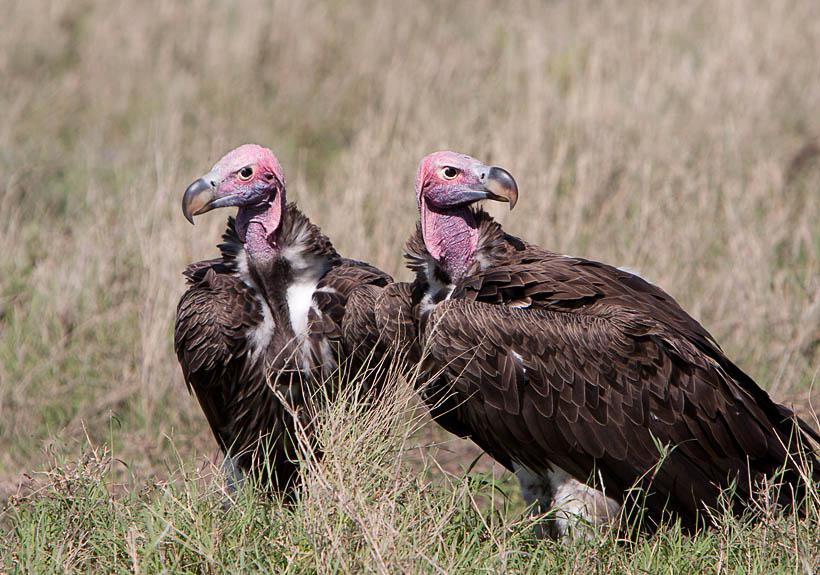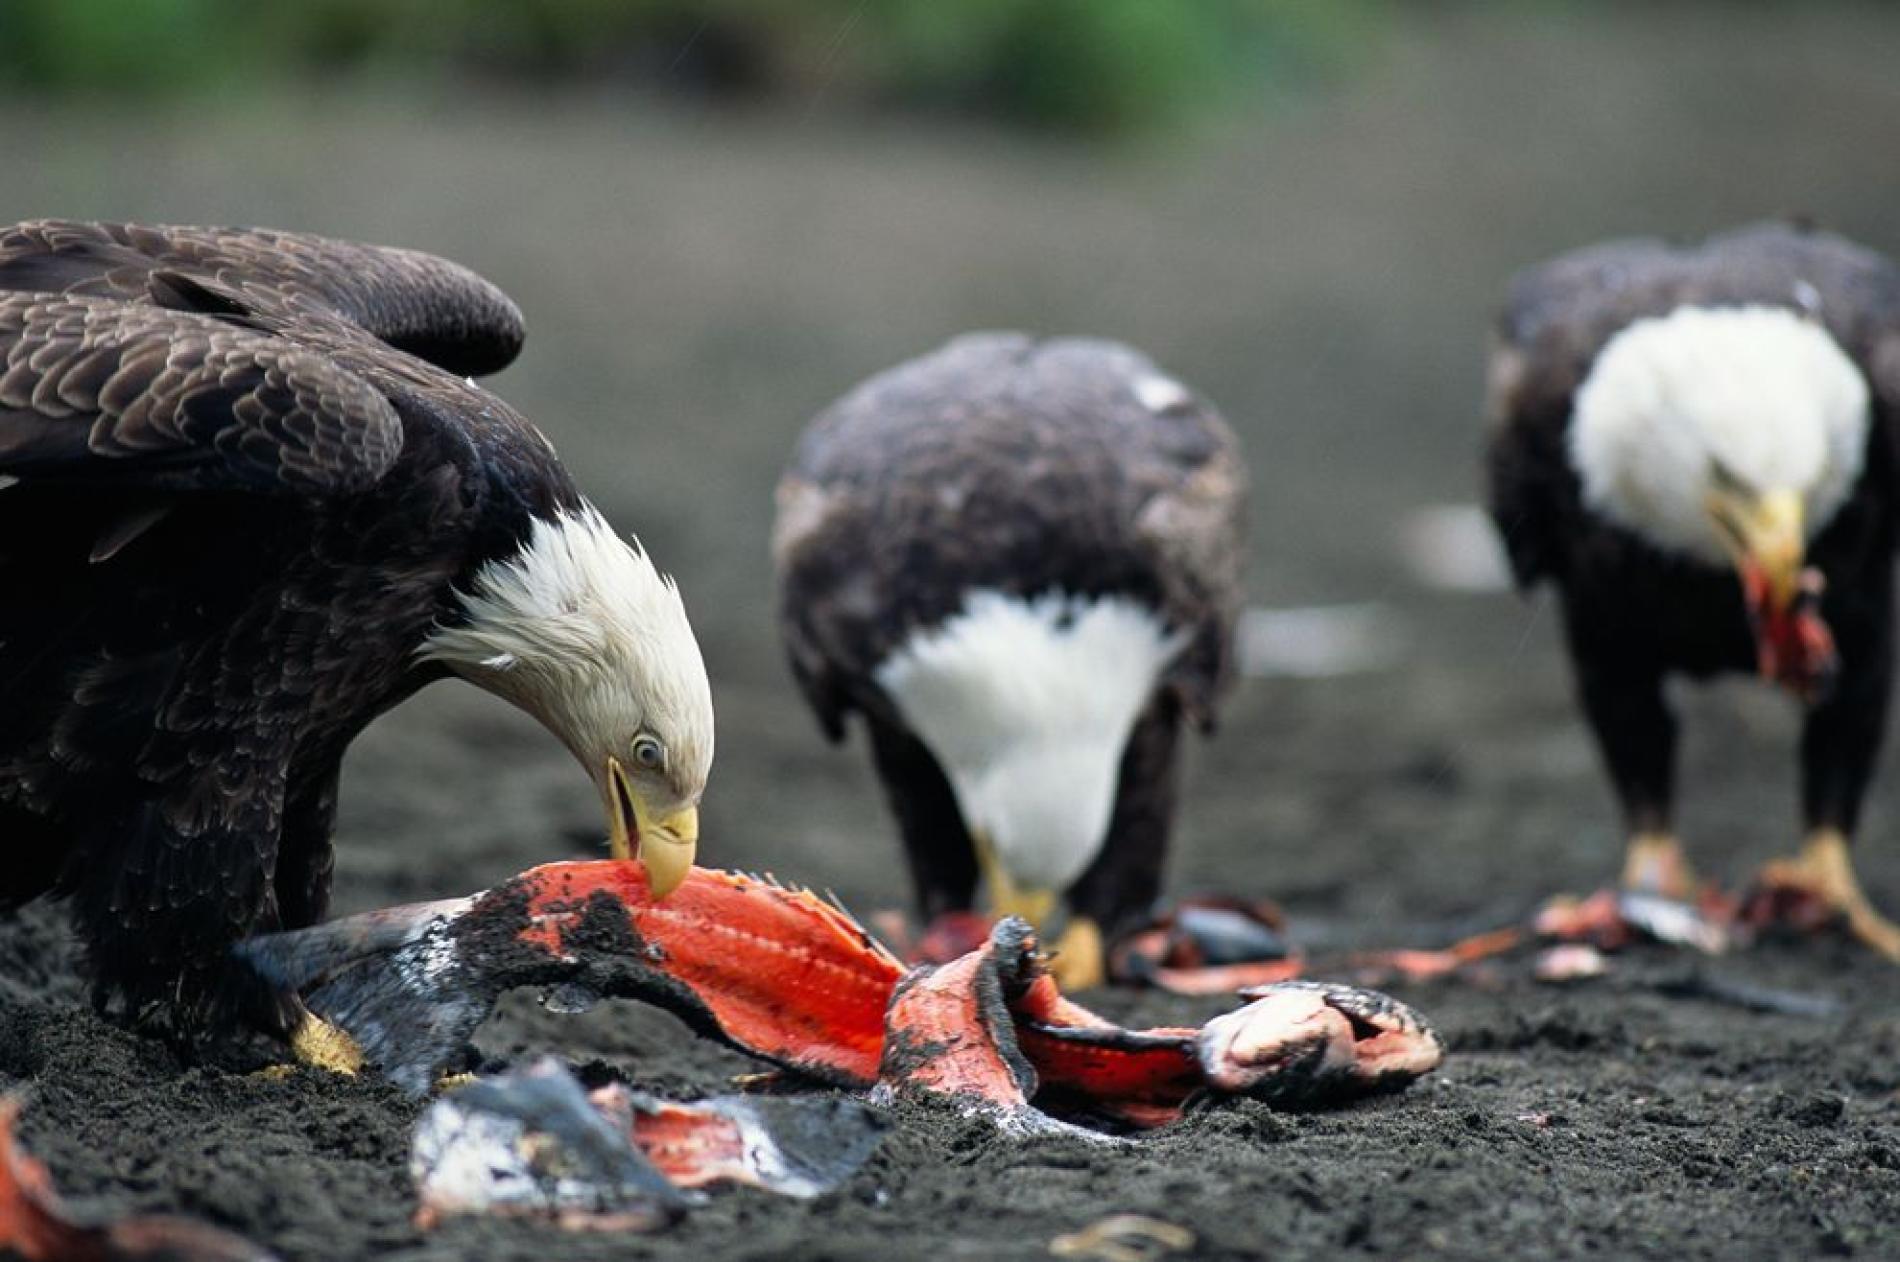The first image is the image on the left, the second image is the image on the right. Assess this claim about the two images: "There are more than four birds.". Correct or not? Answer yes or no. Yes. The first image is the image on the left, the second image is the image on the right. Assess this claim about the two images: "An image shows exactly two side-by-side vultures posed with no space between them.". Correct or not? Answer yes or no. Yes. 